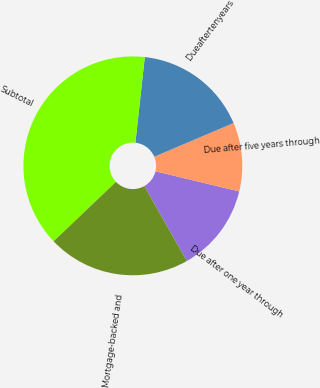Convert chart to OTSL. <chart><loc_0><loc_0><loc_500><loc_500><pie_chart><fcel>Due after one year through<fcel>Due after five years through<fcel>Dueaftertenyears<fcel>Subtotal<fcel>Mortgage-backed and<nl><fcel>13.03%<fcel>10.16%<fcel>16.86%<fcel>38.85%<fcel>21.1%<nl></chart> 